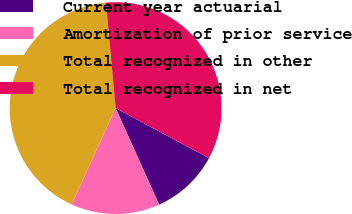Convert chart. <chart><loc_0><loc_0><loc_500><loc_500><pie_chart><fcel>Current year actuarial<fcel>Amortization of prior service<fcel>Total recognized in other<fcel>Total recognized in net<nl><fcel>10.43%<fcel>13.56%<fcel>41.73%<fcel>34.28%<nl></chart> 